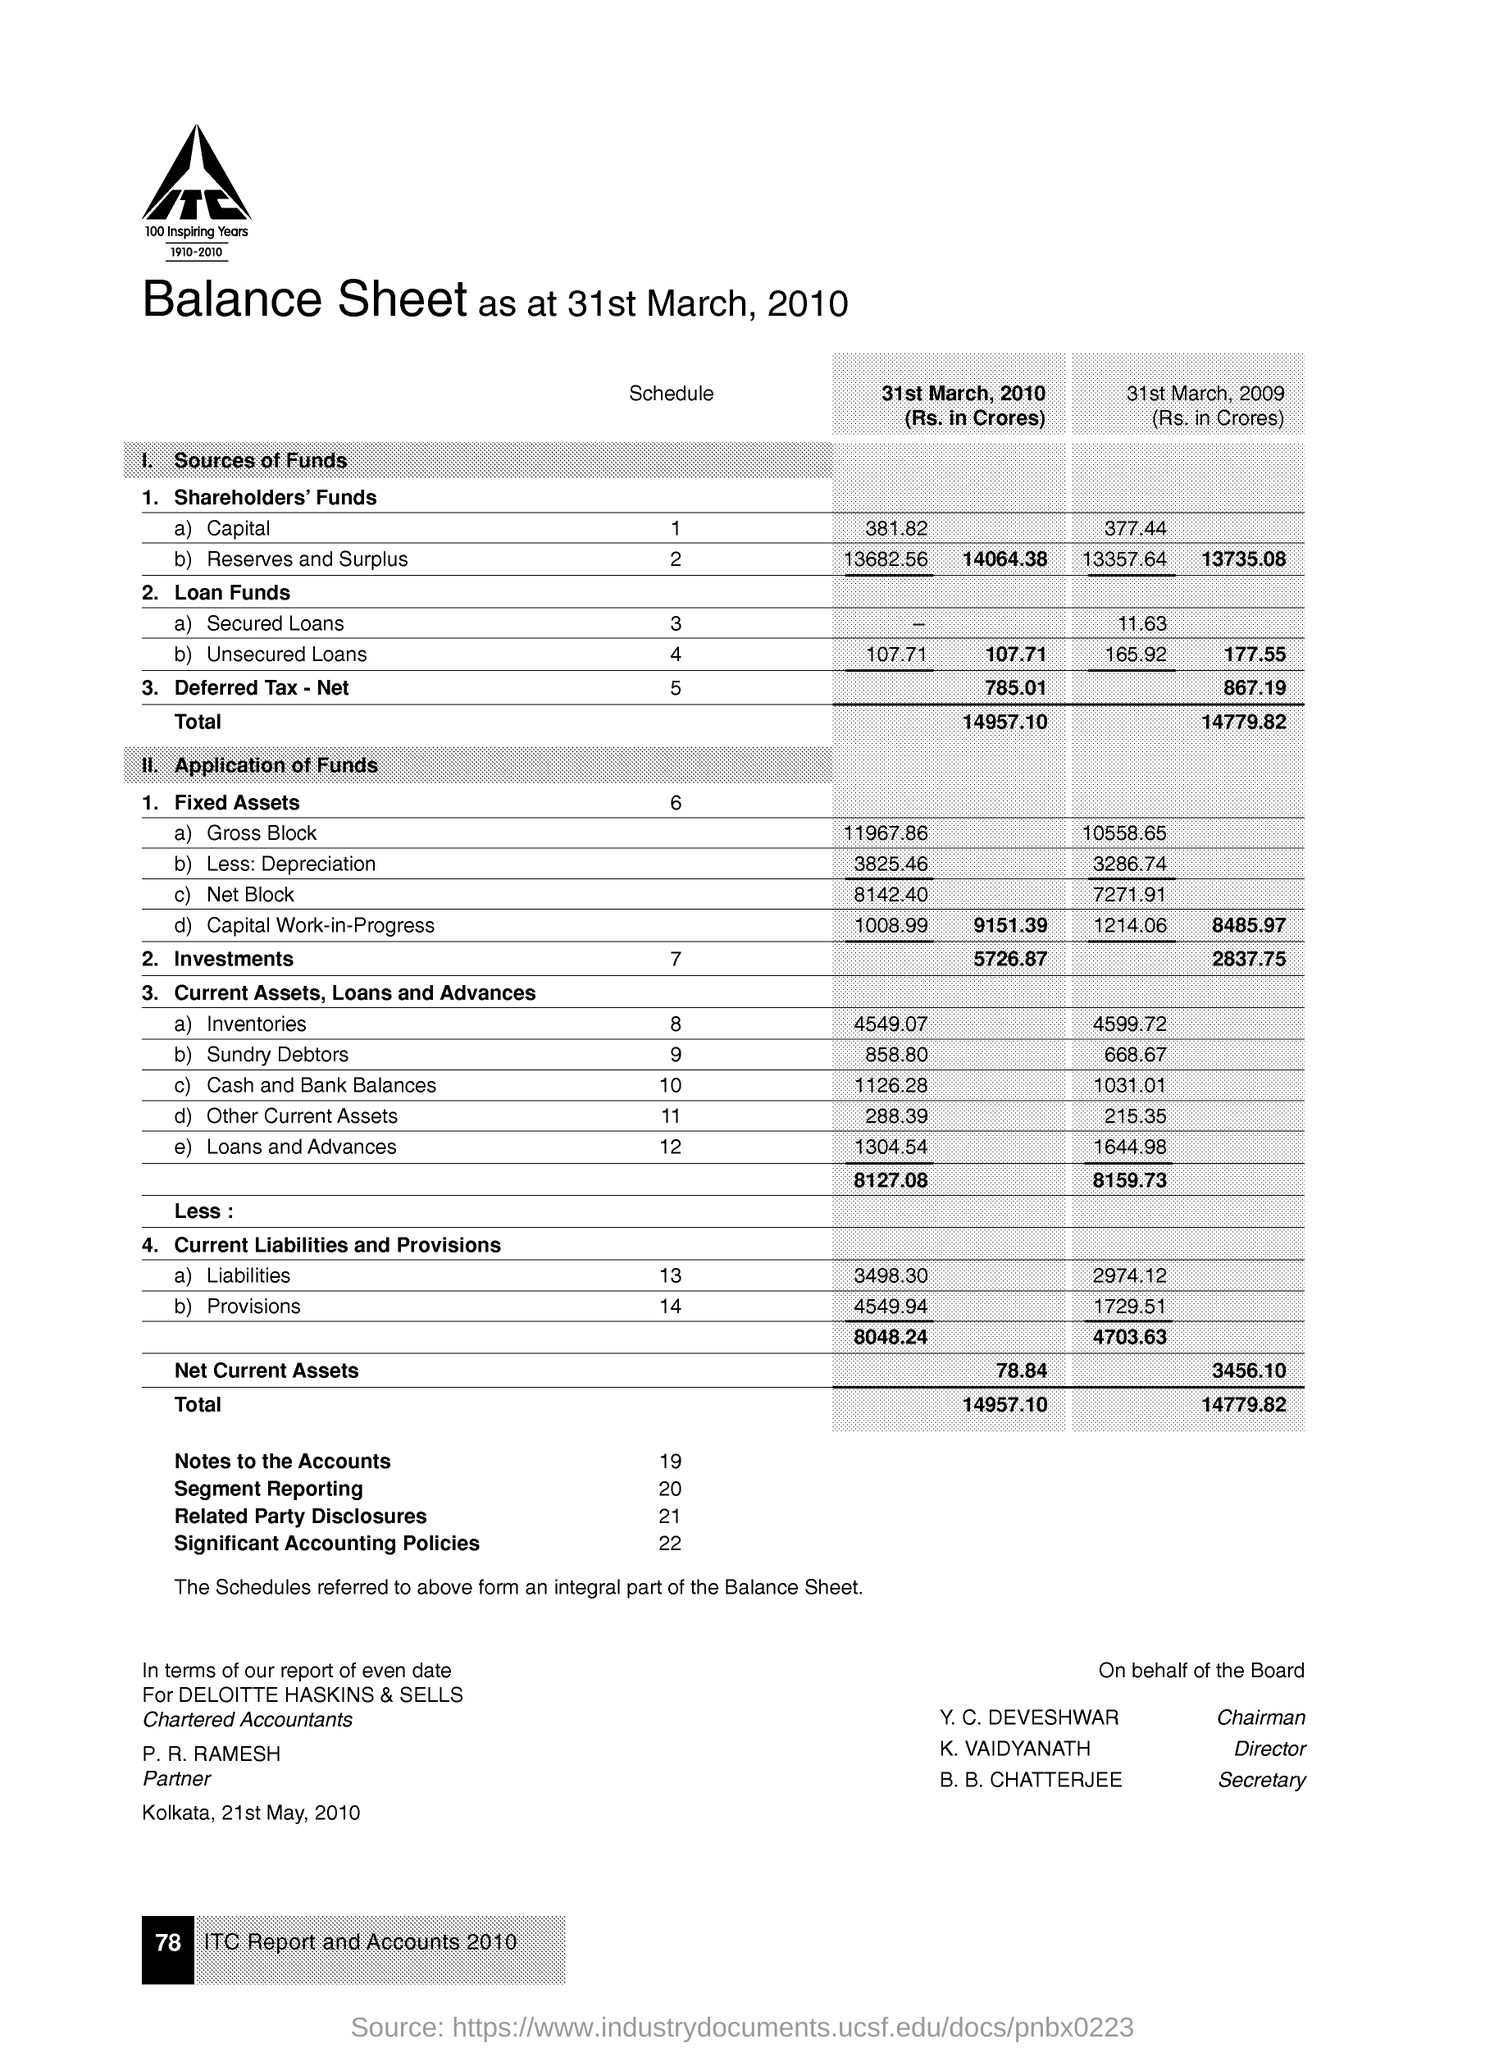What is the shareholder's funds capital as on 31st march ,2010 (rs.in crores)
Offer a terse response. 381.82. What is the gross block in the fixed assets as on 31st march 2010( rs in crores)
Keep it short and to the point. 11967.86. What is the net block in the fixed assets as on 31st march 2010( rs in crores)
Offer a terse response. 8142.40. What is the investments as on  31st march, 2010 (rs in crores)
Offer a very short reply. 5726.87. 